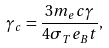Convert formula to latex. <formula><loc_0><loc_0><loc_500><loc_500>\gamma _ { c } = \frac { 3 m _ { e } c \gamma } { 4 \sigma _ { T } e _ { B } t } ,</formula> 